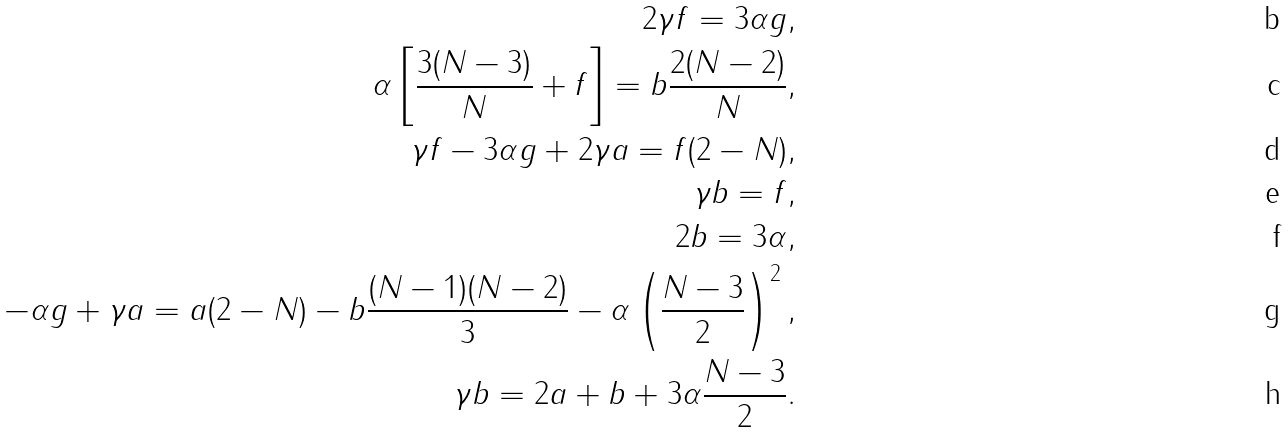Convert formula to latex. <formula><loc_0><loc_0><loc_500><loc_500>2 \gamma f = 3 \alpha g , \\ \alpha \left [ \frac { 3 ( N - 3 ) } { N } + f \right ] = b \frac { 2 ( N - 2 ) } { N } , \\ \gamma f - 3 \alpha g + 2 \gamma a = f ( 2 - N ) , \\ \gamma b = f , \\ 2 b = 3 \alpha , \\ - \alpha g + \gamma a = a ( 2 - N ) - b \frac { ( N - 1 ) ( N - 2 ) } { 3 } - \alpha \left ( \frac { N - 3 } { 2 } \right ) ^ { 2 } , \\ \gamma b = 2 a + b + 3 \alpha \frac { N - 3 } { 2 } .</formula> 